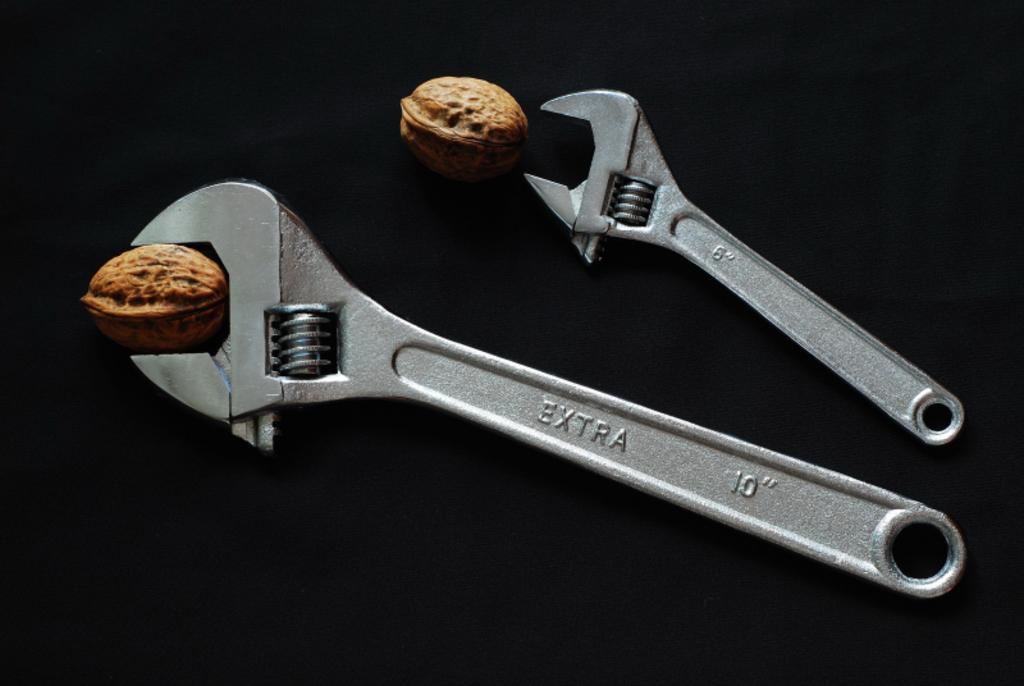What tools are present in the image? There are two wrenches in the image. What objects are not tools in the image? There are two walnuts in the image. What color is the background of the image? The background of the image is black. What type of dress is hanging on the wall in the image? There is no dress present in the image; it only contains wrenches and walnuts. What type of drink is being poured in the image? There is no drink being poured in the image; it only contains wrenches and walnuts. 